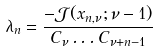Convert formula to latex. <formula><loc_0><loc_0><loc_500><loc_500>\lambda _ { n } = \frac { - \mathcal { J } ( x _ { n , \nu } ; \nu - 1 ) } { C _ { \nu } \dots C _ { \nu + n - 1 } }</formula> 